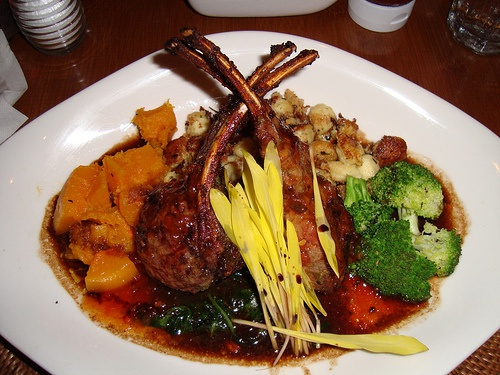Describe the objects in this image and their specific colors. I can see dining table in lightgray, maroon, black, red, and darkgray tones, broccoli in black, darkgreen, and olive tones, carrot in black, red, and maroon tones, cup in black, maroon, and gray tones, and bottle in black, maroon, and gray tones in this image. 